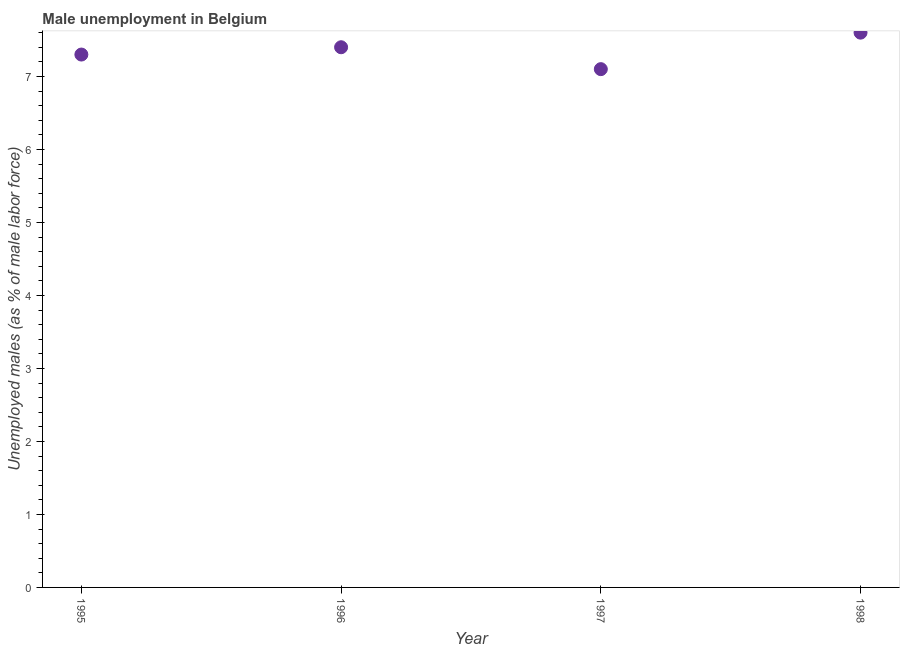What is the unemployed males population in 1996?
Ensure brevity in your answer.  7.4. Across all years, what is the maximum unemployed males population?
Your answer should be very brief. 7.6. Across all years, what is the minimum unemployed males population?
Make the answer very short. 7.1. In which year was the unemployed males population maximum?
Provide a succinct answer. 1998. In which year was the unemployed males population minimum?
Keep it short and to the point. 1997. What is the sum of the unemployed males population?
Keep it short and to the point. 29.4. What is the difference between the unemployed males population in 1996 and 1997?
Offer a terse response. 0.3. What is the average unemployed males population per year?
Provide a short and direct response. 7.35. What is the median unemployed males population?
Keep it short and to the point. 7.35. In how many years, is the unemployed males population greater than 1.6 %?
Provide a succinct answer. 4. What is the ratio of the unemployed males population in 1996 to that in 1997?
Your response must be concise. 1.04. Is the difference between the unemployed males population in 1995 and 1996 greater than the difference between any two years?
Your response must be concise. No. What is the difference between the highest and the second highest unemployed males population?
Make the answer very short. 0.2. Does the unemployed males population monotonically increase over the years?
Make the answer very short. No. How many dotlines are there?
Provide a succinct answer. 1. Are the values on the major ticks of Y-axis written in scientific E-notation?
Your answer should be very brief. No. What is the title of the graph?
Give a very brief answer. Male unemployment in Belgium. What is the label or title of the Y-axis?
Offer a terse response. Unemployed males (as % of male labor force). What is the Unemployed males (as % of male labor force) in 1995?
Offer a terse response. 7.3. What is the Unemployed males (as % of male labor force) in 1996?
Provide a succinct answer. 7.4. What is the Unemployed males (as % of male labor force) in 1997?
Provide a succinct answer. 7.1. What is the Unemployed males (as % of male labor force) in 1998?
Your response must be concise. 7.6. What is the difference between the Unemployed males (as % of male labor force) in 1995 and 1997?
Give a very brief answer. 0.2. What is the difference between the Unemployed males (as % of male labor force) in 1995 and 1998?
Ensure brevity in your answer.  -0.3. What is the difference between the Unemployed males (as % of male labor force) in 1996 and 1997?
Ensure brevity in your answer.  0.3. What is the difference between the Unemployed males (as % of male labor force) in 1997 and 1998?
Offer a terse response. -0.5. What is the ratio of the Unemployed males (as % of male labor force) in 1995 to that in 1996?
Offer a terse response. 0.99. What is the ratio of the Unemployed males (as % of male labor force) in 1995 to that in 1997?
Provide a short and direct response. 1.03. What is the ratio of the Unemployed males (as % of male labor force) in 1995 to that in 1998?
Make the answer very short. 0.96. What is the ratio of the Unemployed males (as % of male labor force) in 1996 to that in 1997?
Provide a succinct answer. 1.04. What is the ratio of the Unemployed males (as % of male labor force) in 1996 to that in 1998?
Offer a terse response. 0.97. What is the ratio of the Unemployed males (as % of male labor force) in 1997 to that in 1998?
Offer a terse response. 0.93. 